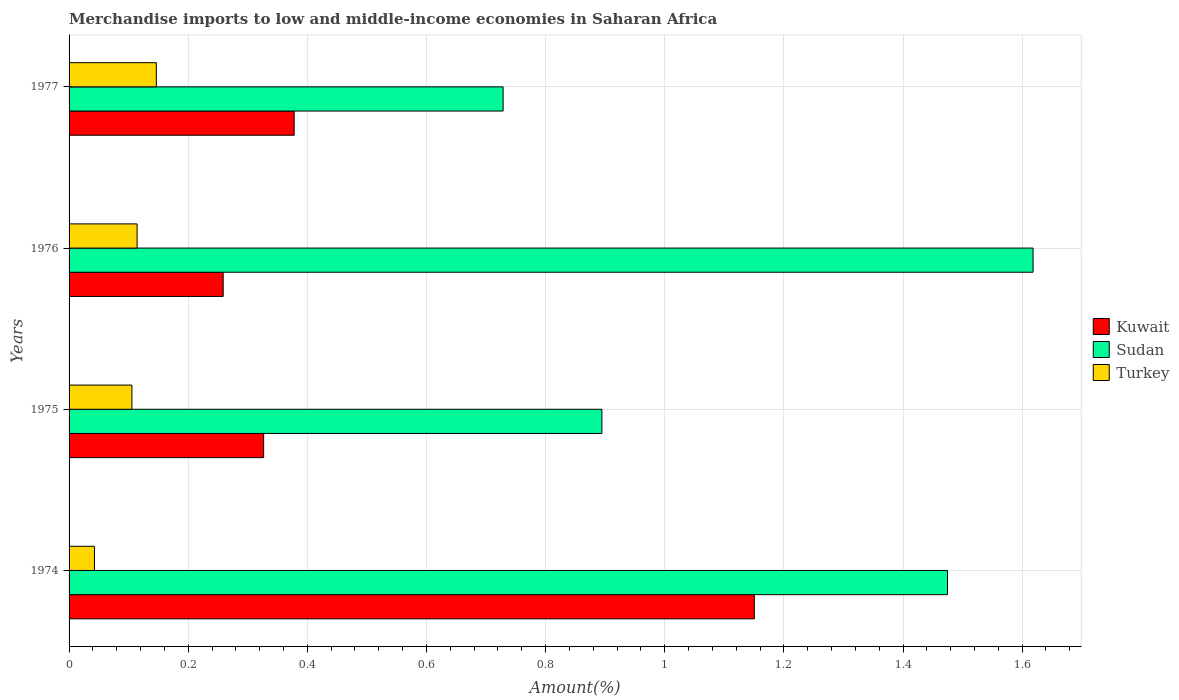How many different coloured bars are there?
Provide a succinct answer. 3. Are the number of bars per tick equal to the number of legend labels?
Ensure brevity in your answer.  Yes. What is the label of the 2nd group of bars from the top?
Offer a terse response. 1976. What is the percentage of amount earned from merchandise imports in Kuwait in 1975?
Give a very brief answer. 0.33. Across all years, what is the maximum percentage of amount earned from merchandise imports in Turkey?
Make the answer very short. 0.15. Across all years, what is the minimum percentage of amount earned from merchandise imports in Sudan?
Ensure brevity in your answer.  0.73. In which year was the percentage of amount earned from merchandise imports in Sudan maximum?
Offer a very short reply. 1976. In which year was the percentage of amount earned from merchandise imports in Kuwait minimum?
Provide a short and direct response. 1976. What is the total percentage of amount earned from merchandise imports in Turkey in the graph?
Ensure brevity in your answer.  0.41. What is the difference between the percentage of amount earned from merchandise imports in Kuwait in 1975 and that in 1977?
Keep it short and to the point. -0.05. What is the difference between the percentage of amount earned from merchandise imports in Sudan in 1975 and the percentage of amount earned from merchandise imports in Turkey in 1976?
Offer a terse response. 0.78. What is the average percentage of amount earned from merchandise imports in Turkey per year?
Your answer should be compact. 0.1. In the year 1976, what is the difference between the percentage of amount earned from merchandise imports in Sudan and percentage of amount earned from merchandise imports in Turkey?
Your response must be concise. 1.5. What is the ratio of the percentage of amount earned from merchandise imports in Turkey in 1974 to that in 1977?
Give a very brief answer. 0.29. What is the difference between the highest and the second highest percentage of amount earned from merchandise imports in Kuwait?
Ensure brevity in your answer.  0.77. What is the difference between the highest and the lowest percentage of amount earned from merchandise imports in Turkey?
Offer a terse response. 0.1. Is the sum of the percentage of amount earned from merchandise imports in Kuwait in 1975 and 1976 greater than the maximum percentage of amount earned from merchandise imports in Turkey across all years?
Give a very brief answer. Yes. What does the 2nd bar from the top in 1976 represents?
Your answer should be compact. Sudan. What does the 3rd bar from the bottom in 1977 represents?
Provide a succinct answer. Turkey. Are all the bars in the graph horizontal?
Give a very brief answer. Yes. How many years are there in the graph?
Keep it short and to the point. 4. Does the graph contain any zero values?
Your response must be concise. No. Where does the legend appear in the graph?
Make the answer very short. Center right. How many legend labels are there?
Ensure brevity in your answer.  3. What is the title of the graph?
Keep it short and to the point. Merchandise imports to low and middle-income economies in Saharan Africa. Does "Hungary" appear as one of the legend labels in the graph?
Make the answer very short. No. What is the label or title of the X-axis?
Your answer should be very brief. Amount(%). What is the Amount(%) in Kuwait in 1974?
Your answer should be compact. 1.15. What is the Amount(%) of Sudan in 1974?
Offer a terse response. 1.47. What is the Amount(%) of Turkey in 1974?
Your answer should be compact. 0.04. What is the Amount(%) of Kuwait in 1975?
Your answer should be very brief. 0.33. What is the Amount(%) of Sudan in 1975?
Keep it short and to the point. 0.89. What is the Amount(%) of Turkey in 1975?
Your answer should be compact. 0.11. What is the Amount(%) in Kuwait in 1976?
Give a very brief answer. 0.26. What is the Amount(%) of Sudan in 1976?
Give a very brief answer. 1.62. What is the Amount(%) of Turkey in 1976?
Ensure brevity in your answer.  0.11. What is the Amount(%) in Kuwait in 1977?
Provide a succinct answer. 0.38. What is the Amount(%) in Sudan in 1977?
Your answer should be compact. 0.73. What is the Amount(%) in Turkey in 1977?
Make the answer very short. 0.15. Across all years, what is the maximum Amount(%) of Kuwait?
Give a very brief answer. 1.15. Across all years, what is the maximum Amount(%) of Sudan?
Your response must be concise. 1.62. Across all years, what is the maximum Amount(%) in Turkey?
Provide a short and direct response. 0.15. Across all years, what is the minimum Amount(%) in Kuwait?
Provide a short and direct response. 0.26. Across all years, what is the minimum Amount(%) in Sudan?
Offer a very short reply. 0.73. Across all years, what is the minimum Amount(%) of Turkey?
Ensure brevity in your answer.  0.04. What is the total Amount(%) in Kuwait in the graph?
Make the answer very short. 2.11. What is the total Amount(%) of Sudan in the graph?
Make the answer very short. 4.72. What is the total Amount(%) in Turkey in the graph?
Offer a very short reply. 0.41. What is the difference between the Amount(%) in Kuwait in 1974 and that in 1975?
Ensure brevity in your answer.  0.82. What is the difference between the Amount(%) in Sudan in 1974 and that in 1975?
Provide a short and direct response. 0.58. What is the difference between the Amount(%) in Turkey in 1974 and that in 1975?
Make the answer very short. -0.06. What is the difference between the Amount(%) of Kuwait in 1974 and that in 1976?
Offer a very short reply. 0.89. What is the difference between the Amount(%) of Sudan in 1974 and that in 1976?
Offer a very short reply. -0.14. What is the difference between the Amount(%) of Turkey in 1974 and that in 1976?
Ensure brevity in your answer.  -0.07. What is the difference between the Amount(%) of Kuwait in 1974 and that in 1977?
Offer a terse response. 0.77. What is the difference between the Amount(%) of Sudan in 1974 and that in 1977?
Offer a very short reply. 0.75. What is the difference between the Amount(%) in Turkey in 1974 and that in 1977?
Give a very brief answer. -0.1. What is the difference between the Amount(%) in Kuwait in 1975 and that in 1976?
Your answer should be compact. 0.07. What is the difference between the Amount(%) in Sudan in 1975 and that in 1976?
Make the answer very short. -0.72. What is the difference between the Amount(%) in Turkey in 1975 and that in 1976?
Give a very brief answer. -0.01. What is the difference between the Amount(%) of Kuwait in 1975 and that in 1977?
Give a very brief answer. -0.05. What is the difference between the Amount(%) of Sudan in 1975 and that in 1977?
Your answer should be very brief. 0.17. What is the difference between the Amount(%) of Turkey in 1975 and that in 1977?
Your response must be concise. -0.04. What is the difference between the Amount(%) of Kuwait in 1976 and that in 1977?
Give a very brief answer. -0.12. What is the difference between the Amount(%) in Sudan in 1976 and that in 1977?
Offer a very short reply. 0.89. What is the difference between the Amount(%) in Turkey in 1976 and that in 1977?
Your response must be concise. -0.03. What is the difference between the Amount(%) in Kuwait in 1974 and the Amount(%) in Sudan in 1975?
Your response must be concise. 0.26. What is the difference between the Amount(%) of Kuwait in 1974 and the Amount(%) of Turkey in 1975?
Your answer should be compact. 1.04. What is the difference between the Amount(%) in Sudan in 1974 and the Amount(%) in Turkey in 1975?
Make the answer very short. 1.37. What is the difference between the Amount(%) in Kuwait in 1974 and the Amount(%) in Sudan in 1976?
Your answer should be very brief. -0.47. What is the difference between the Amount(%) of Kuwait in 1974 and the Amount(%) of Turkey in 1976?
Make the answer very short. 1.04. What is the difference between the Amount(%) in Sudan in 1974 and the Amount(%) in Turkey in 1976?
Give a very brief answer. 1.36. What is the difference between the Amount(%) in Kuwait in 1974 and the Amount(%) in Sudan in 1977?
Keep it short and to the point. 0.42. What is the difference between the Amount(%) of Kuwait in 1974 and the Amount(%) of Turkey in 1977?
Your answer should be compact. 1. What is the difference between the Amount(%) in Sudan in 1974 and the Amount(%) in Turkey in 1977?
Ensure brevity in your answer.  1.33. What is the difference between the Amount(%) of Kuwait in 1975 and the Amount(%) of Sudan in 1976?
Make the answer very short. -1.29. What is the difference between the Amount(%) of Kuwait in 1975 and the Amount(%) of Turkey in 1976?
Provide a short and direct response. 0.21. What is the difference between the Amount(%) of Sudan in 1975 and the Amount(%) of Turkey in 1976?
Give a very brief answer. 0.78. What is the difference between the Amount(%) of Kuwait in 1975 and the Amount(%) of Sudan in 1977?
Give a very brief answer. -0.4. What is the difference between the Amount(%) in Kuwait in 1975 and the Amount(%) in Turkey in 1977?
Give a very brief answer. 0.18. What is the difference between the Amount(%) in Sudan in 1975 and the Amount(%) in Turkey in 1977?
Make the answer very short. 0.75. What is the difference between the Amount(%) in Kuwait in 1976 and the Amount(%) in Sudan in 1977?
Ensure brevity in your answer.  -0.47. What is the difference between the Amount(%) of Kuwait in 1976 and the Amount(%) of Turkey in 1977?
Offer a very short reply. 0.11. What is the difference between the Amount(%) in Sudan in 1976 and the Amount(%) in Turkey in 1977?
Offer a very short reply. 1.47. What is the average Amount(%) in Kuwait per year?
Offer a very short reply. 0.53. What is the average Amount(%) of Sudan per year?
Ensure brevity in your answer.  1.18. What is the average Amount(%) of Turkey per year?
Make the answer very short. 0.1. In the year 1974, what is the difference between the Amount(%) of Kuwait and Amount(%) of Sudan?
Offer a terse response. -0.32. In the year 1974, what is the difference between the Amount(%) of Kuwait and Amount(%) of Turkey?
Give a very brief answer. 1.11. In the year 1974, what is the difference between the Amount(%) of Sudan and Amount(%) of Turkey?
Give a very brief answer. 1.43. In the year 1975, what is the difference between the Amount(%) of Kuwait and Amount(%) of Sudan?
Make the answer very short. -0.57. In the year 1975, what is the difference between the Amount(%) in Kuwait and Amount(%) in Turkey?
Give a very brief answer. 0.22. In the year 1975, what is the difference between the Amount(%) of Sudan and Amount(%) of Turkey?
Ensure brevity in your answer.  0.79. In the year 1976, what is the difference between the Amount(%) of Kuwait and Amount(%) of Sudan?
Provide a succinct answer. -1.36. In the year 1976, what is the difference between the Amount(%) in Kuwait and Amount(%) in Turkey?
Provide a succinct answer. 0.14. In the year 1976, what is the difference between the Amount(%) of Sudan and Amount(%) of Turkey?
Offer a terse response. 1.5. In the year 1977, what is the difference between the Amount(%) of Kuwait and Amount(%) of Sudan?
Make the answer very short. -0.35. In the year 1977, what is the difference between the Amount(%) in Kuwait and Amount(%) in Turkey?
Offer a terse response. 0.23. In the year 1977, what is the difference between the Amount(%) in Sudan and Amount(%) in Turkey?
Keep it short and to the point. 0.58. What is the ratio of the Amount(%) of Kuwait in 1974 to that in 1975?
Your answer should be very brief. 3.52. What is the ratio of the Amount(%) of Sudan in 1974 to that in 1975?
Your answer should be compact. 1.65. What is the ratio of the Amount(%) of Turkey in 1974 to that in 1975?
Keep it short and to the point. 0.4. What is the ratio of the Amount(%) of Kuwait in 1974 to that in 1976?
Provide a short and direct response. 4.45. What is the ratio of the Amount(%) in Sudan in 1974 to that in 1976?
Your answer should be compact. 0.91. What is the ratio of the Amount(%) in Turkey in 1974 to that in 1976?
Provide a short and direct response. 0.37. What is the ratio of the Amount(%) in Kuwait in 1974 to that in 1977?
Provide a succinct answer. 3.04. What is the ratio of the Amount(%) in Sudan in 1974 to that in 1977?
Offer a very short reply. 2.02. What is the ratio of the Amount(%) in Turkey in 1974 to that in 1977?
Offer a very short reply. 0.29. What is the ratio of the Amount(%) in Kuwait in 1975 to that in 1976?
Give a very brief answer. 1.26. What is the ratio of the Amount(%) of Sudan in 1975 to that in 1976?
Offer a very short reply. 0.55. What is the ratio of the Amount(%) in Turkey in 1975 to that in 1976?
Give a very brief answer. 0.92. What is the ratio of the Amount(%) of Kuwait in 1975 to that in 1977?
Offer a very short reply. 0.86. What is the ratio of the Amount(%) in Sudan in 1975 to that in 1977?
Provide a succinct answer. 1.23. What is the ratio of the Amount(%) of Turkey in 1975 to that in 1977?
Your response must be concise. 0.72. What is the ratio of the Amount(%) of Kuwait in 1976 to that in 1977?
Ensure brevity in your answer.  0.68. What is the ratio of the Amount(%) of Sudan in 1976 to that in 1977?
Keep it short and to the point. 2.22. What is the ratio of the Amount(%) in Turkey in 1976 to that in 1977?
Your answer should be compact. 0.78. What is the difference between the highest and the second highest Amount(%) in Kuwait?
Make the answer very short. 0.77. What is the difference between the highest and the second highest Amount(%) of Sudan?
Ensure brevity in your answer.  0.14. What is the difference between the highest and the second highest Amount(%) of Turkey?
Offer a very short reply. 0.03. What is the difference between the highest and the lowest Amount(%) of Kuwait?
Make the answer very short. 0.89. What is the difference between the highest and the lowest Amount(%) in Sudan?
Ensure brevity in your answer.  0.89. What is the difference between the highest and the lowest Amount(%) of Turkey?
Your answer should be very brief. 0.1. 